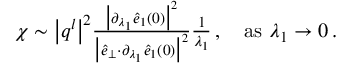Convert formula to latex. <formula><loc_0><loc_0><loc_500><loc_500>\begin{array} { r } { \chi \sim \left | q ^ { l } \right | ^ { 2 } \frac { \left | \partial _ { \lambda _ { 1 } } \hat { e } _ { 1 } ( 0 ) \right | ^ { 2 } } { \left | \hat { e } _ { \perp } { \cdot } \partial _ { \lambda _ { 1 } } \hat { e } _ { 1 } ( 0 ) \right | ^ { 2 } } \frac { 1 } { \lambda _ { 1 } } \, , a s \lambda _ { 1 } \rightarrow 0 \, . } \end{array}</formula> 